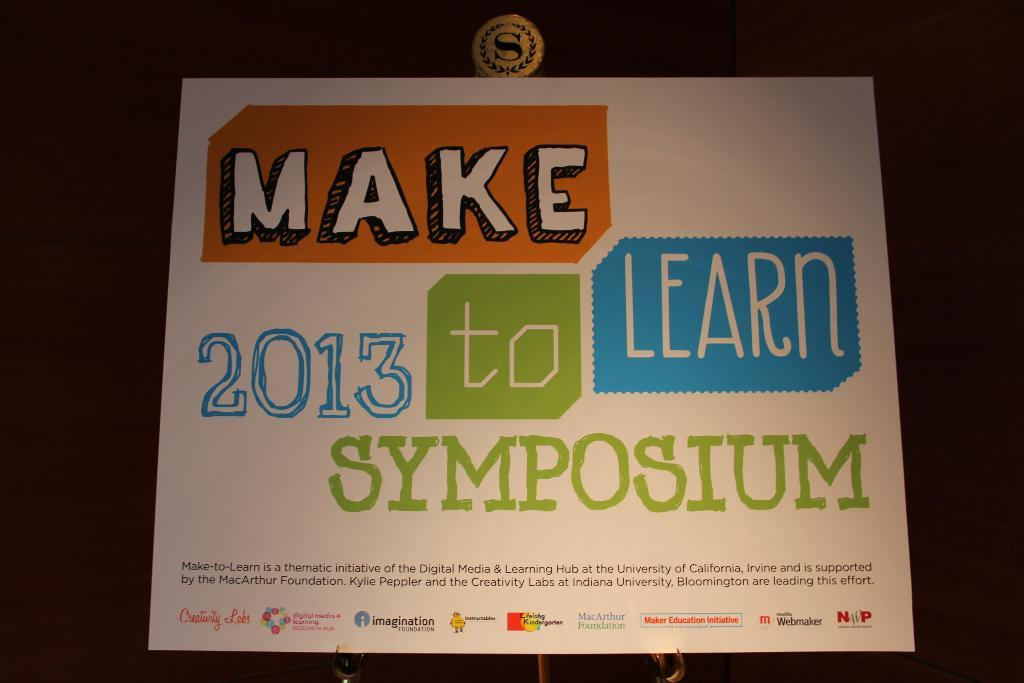<image>
Share a concise interpretation of the image provided. a sign for a symposium called Make to learn 